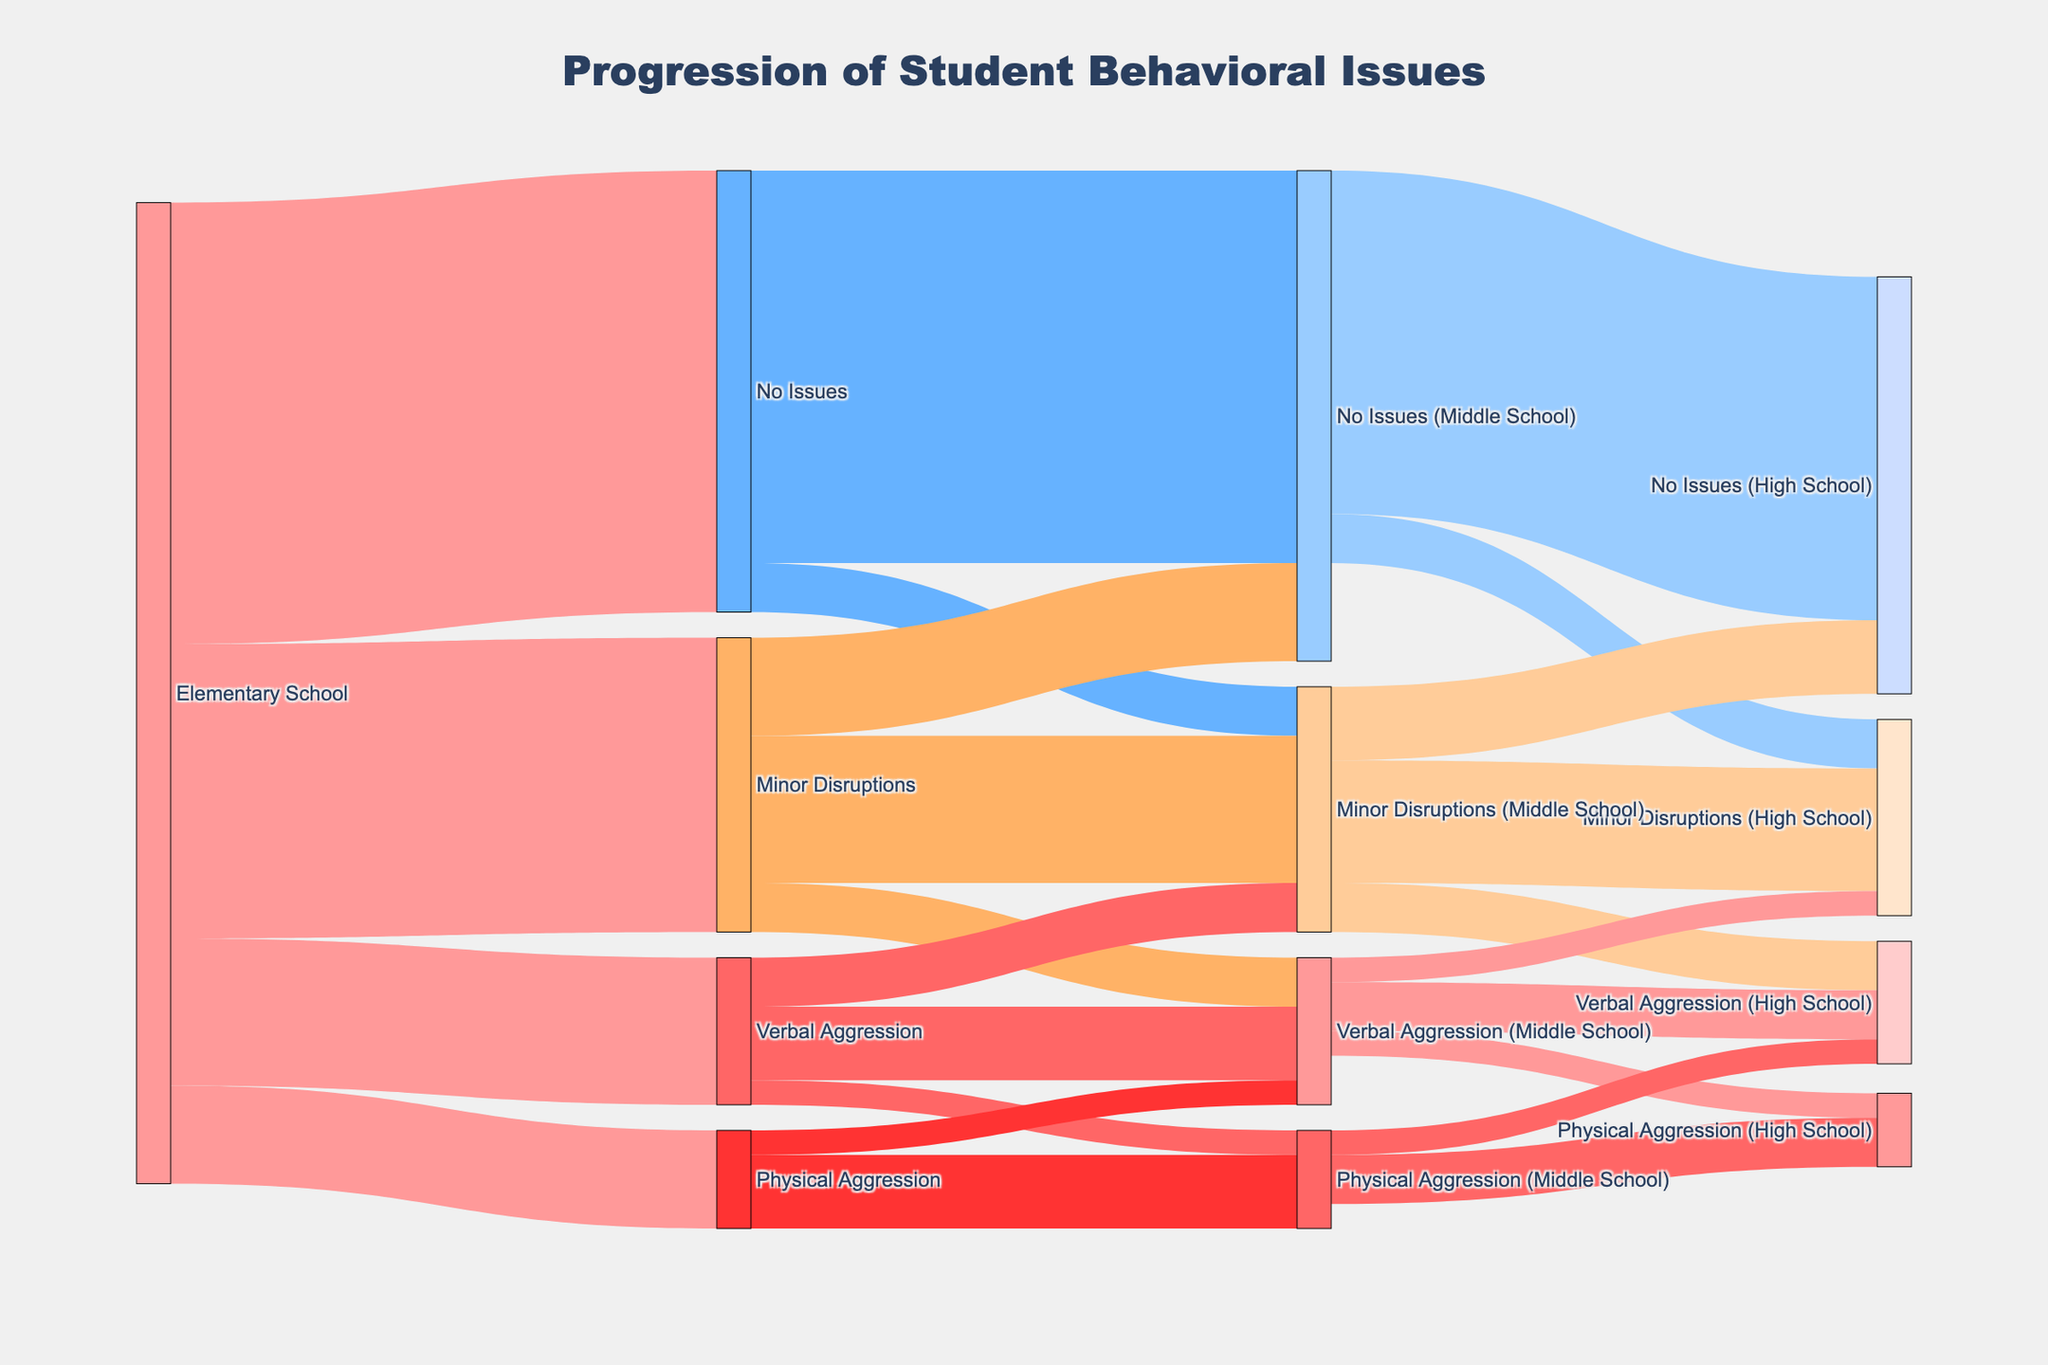How many students experienced "No Issues" in Elementary School? According to the Sankey Diagram, the number of students who had "No Issues" in Elementary School is represented by the value linked to "No Issues" from the "Elementary School" source.
Answer: 450 What is the total number of students with "Minor Disruptions" in Middle School, coming from all Elementary School categories? To find this, sum the values from "No Issues" to "Minor Disruptions (Middle School)" (50), "Minor Disruptions" to "Minor Disruptions (Middle School)" (150), and "Verbal Aggression" to "Minor Disruptions (Middle School)" (50).
Answer: 250 Which type of behavioral issue showed the highest progression from Elementary School to Middle School? Comparing the values for each type of behavioral issue from Elementary School to Middle School: "No Issues" (400 + 50), "Minor Disruptions" (100 + 150 + 50), "Verbal Aggression" (50 + 75 + 25), and "Physical Aggression" (25 + 75), "No Issues" shows the highest progression with a total of 450.
Answer: No Issues How many students transitioned from "Verbal Aggression" in Middle School to "Physical Aggression" in High School? According to the Sankey Diagram, the value that links "Verbal Aggression (Middle School)" to "Physical Aggression (High School)" shows this number.
Answer: 25 What percentage of students with "No Issues" in Middle School continued to have "No Issues" in High School? There were 350 students who continued to have "No Issues" in High School out of 400 students with "No Issues" in Middle School. The percentage is calculated as (350 / 400) * 100.
Answer: 87.5% Which initial category in Elementary School had the least progression to "Physical Aggression" in Middle School? Comparing the values: "Elementary School" to "Physical Aggression (Middle School)" from all categories: "Verbal Aggression" (25) and "Physical Aggression" (75), "Verbal Aggression" has the least progression.
Answer: Verbal Aggression How many students experienced "Minor Disruptions" continuously from Elementary to High School? To determine this, find the value linked from "Minor Disruptions" in Elementary School to "Minor Disruptions (Middle School)" (150) and from "Minor Disruptions (Middle School)" to "Minor Disruptions (High School)" (125). Trace only those who followed this path.
Answer: 125 students What is the most common behavioral outcome for students who started with "Minor Disruptions" in Elementary School by the time they reached High School? For students who started with "Minor Disruptions" in Elementary School, follow the paths to High School: No Issues (75), Minor Disruptions (125), Verbal Aggression (50). The most common outcome in High School is "Minor Disruptions".
Answer: Minor Disruptions How does the number of students with "Physical Aggression" in High School compare to those with "Verbal Aggression" in High School? According to the diagram, students with "Physical Aggression (High School)" total 50, and students with "Verbal Aggression (High School)" total 75.
Answer: 50 compared to 75 What is the trend in the number of students experiencing "Physical Aggression" from Elementary through High School? Trace "Physical Aggression" path: 100 in Elementary, splitting into 25 (Verbal Aggression) and 75 (Physical Aggression) in Middle School, and in High School combined they account for 50 (Physical) + 25 (Verbal). A decreasing trend from 100 to fewer students.
Answer: Decreasing trend 